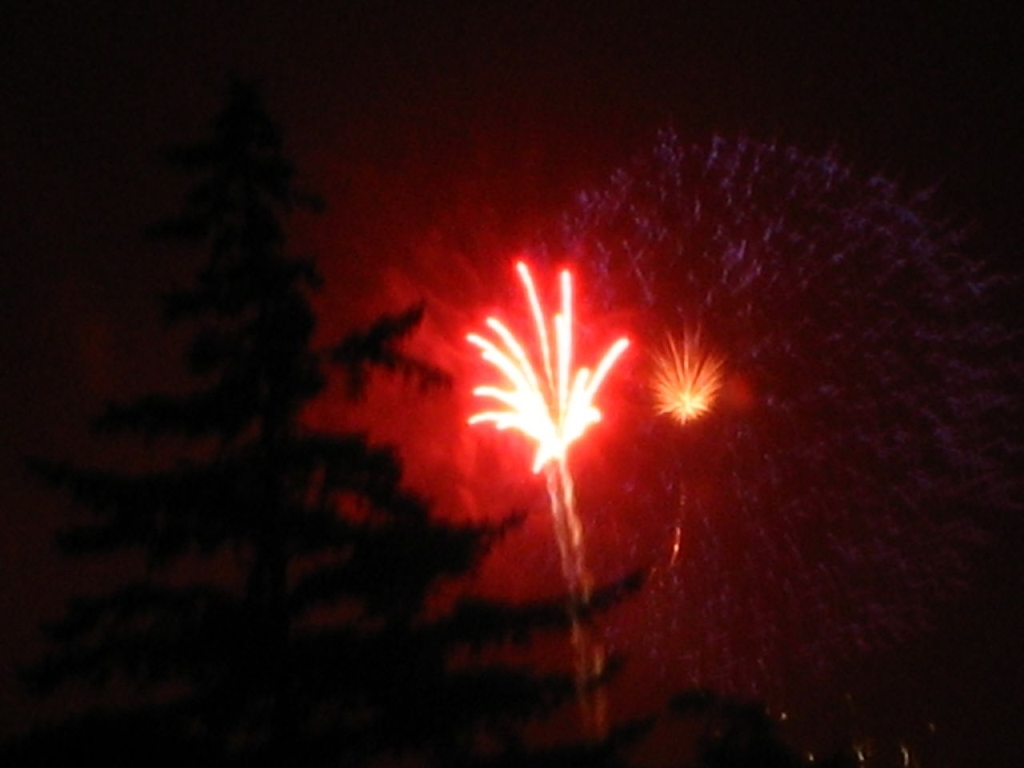What type of event could this image be depicting, and how can you deduce that? This image seems to depict a fireworks display, possibly during a celebration or a public event. This can be deduced from the bursts of light resembling fireworks in the night sky, which are common in festivities and significant occasions. 